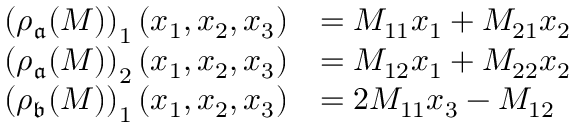<formula> <loc_0><loc_0><loc_500><loc_500>\begin{array} { r l } { \left ( \rho _ { \mathfrak { a } } ( M ) \right ) _ { 1 } ( x _ { 1 } , x _ { 2 } , x _ { 3 } ) } & { = M _ { 1 1 } x _ { 1 } + M _ { 2 1 } x _ { 2 } } \\ { \left ( \rho _ { \mathfrak { a } } ( M ) \right ) _ { 2 } ( x _ { 1 } , x _ { 2 } , x _ { 3 } ) } & { = M _ { 1 2 } x _ { 1 } + M _ { 2 2 } x _ { 2 } } \\ { \left ( \rho _ { \mathfrak { b } } ( M ) \right ) _ { 1 } ( x _ { 1 } , x _ { 2 } , x _ { 3 } ) } & { = 2 M _ { 1 1 } x _ { 3 } - M _ { 1 2 } } \end{array}</formula> 